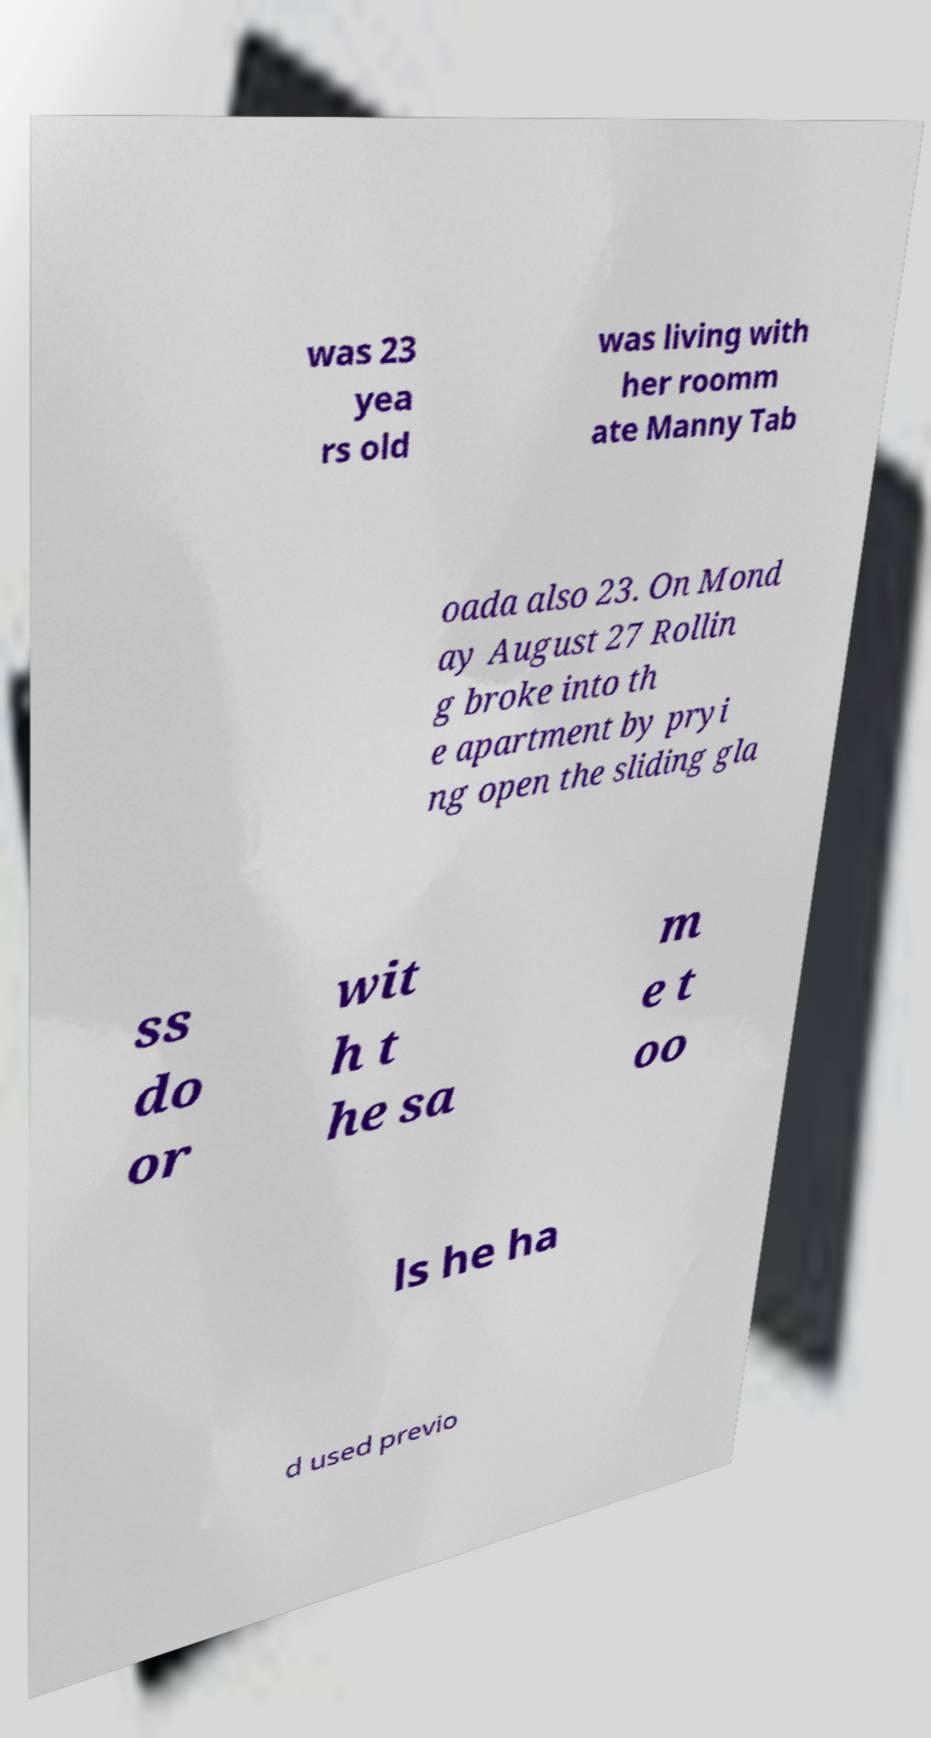Can you accurately transcribe the text from the provided image for me? was 23 yea rs old was living with her roomm ate Manny Tab oada also 23. On Mond ay August 27 Rollin g broke into th e apartment by pryi ng open the sliding gla ss do or wit h t he sa m e t oo ls he ha d used previo 